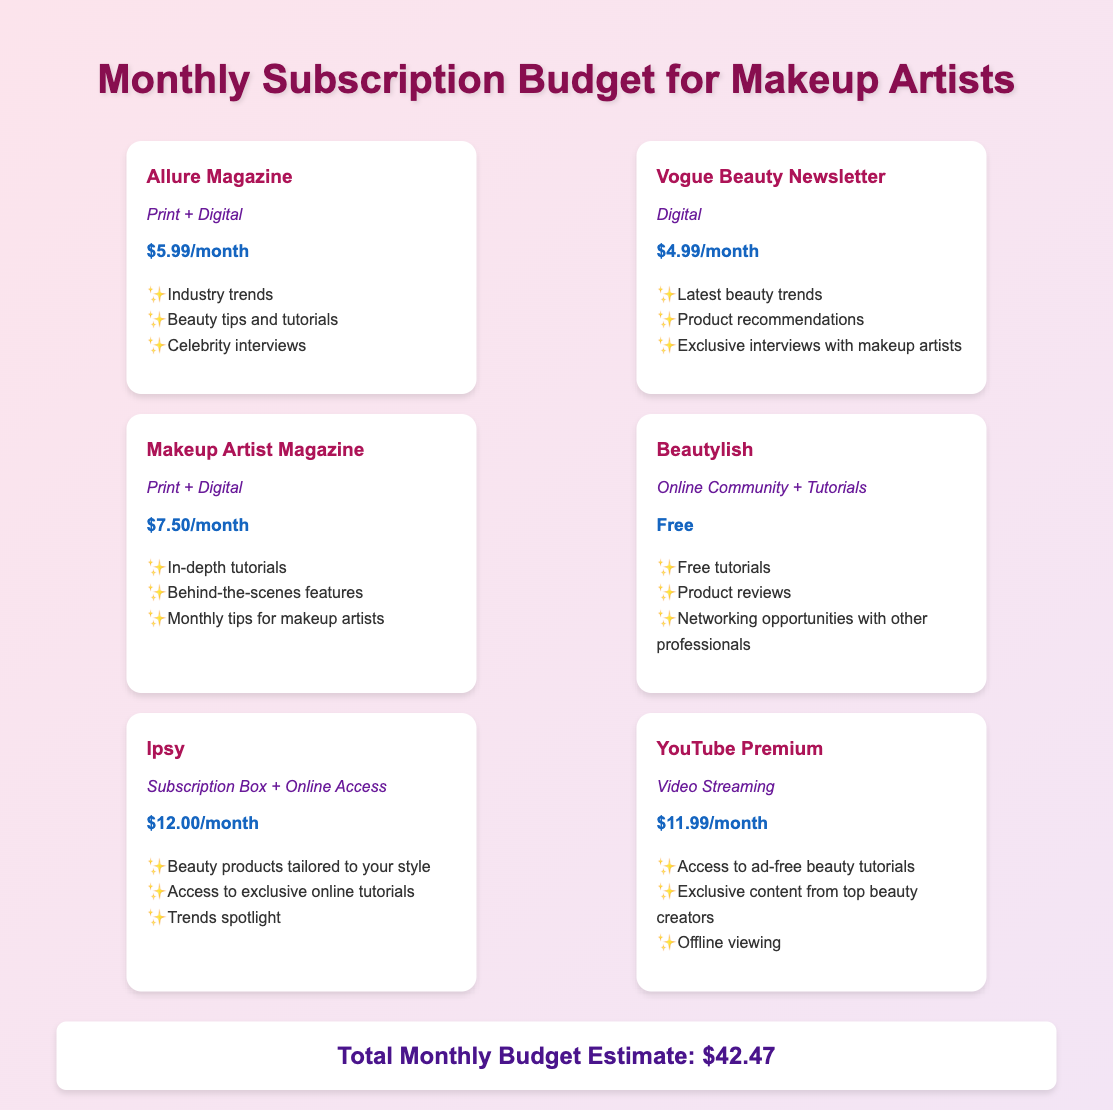What is the subscription fee for Allure Magazine? The fee for Allure Magazine is clearly stated in the document as $5.99/month.
Answer: $5.99/month How many subscriptions have a fee? The document lists several subscription fees, and by counting them, we find that there are five subscriptions with fees.
Answer: 5 What platform offers free access? The document specifies that Beautylish is the only platform listed that offers free access.
Answer: Beautylish What type of content does Ipsy provide? Ipsy is described as a subscription box and online access, and the document mentions specific content such as beauty products and online tutorials.
Answer: Subscription Box + Online Access What is the total monthly budget estimate? The document provides a specific total monthly budget estimate, which is calculated by adding the individual subscription fees.
Answer: $42.47 Which platform is focused on print and digital content? The document indicates that both Allure Magazine and Makeup Artist Magazine offer print and digital content.
Answer: Allure Magazine, Makeup Artist Magazine How much does YouTube Premium cost per month? The document states the fee for YouTube Premium as $11.99/month.
Answer: $11.99/month What color is used for the fee text? The document specifies that the fee text is colored in a specific shade, which is blue.
Answer: Blue 